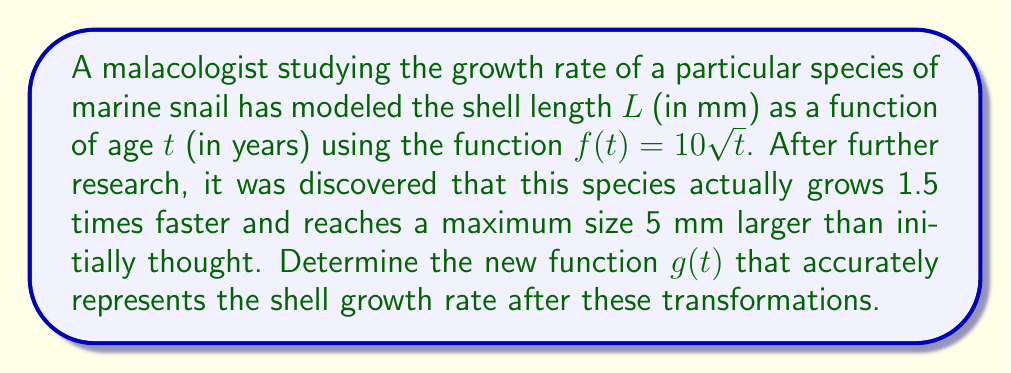Help me with this question. Let's approach this step-by-step:

1) The original function is $f(t) = 10\sqrt{t}$.

2) The species grows 1.5 times faster. This means we need to compress the function horizontally by a factor of 1.5. To do this, we replace $t$ with $\frac{t}{1.5}$:

   $f(\frac{t}{1.5}) = 10\sqrt{\frac{t}{1.5}}$

3) The species reaches a maximum size 5 mm larger. This means we need to shift the function vertically by 5 units:

   $f(\frac{t}{1.5}) + 5 = 10\sqrt{\frac{t}{1.5}} + 5$

4) Now, let's simplify the square root:

   $10\sqrt{\frac{t}{1.5}} + 5 = 10\sqrt{\frac{2t}{3}} + 5$

5) Therefore, the new function $g(t)$ that represents the adjusted growth rate is:

   $g(t) = 10\sqrt{\frac{2t}{3}} + 5$

This function represents a shell that grows 1.5 times faster (compressed horizontally) and reaches a maximum size 5 mm larger (shifted up vertically) compared to the original model.
Answer: $g(t) = 10\sqrt{\frac{2t}{3}} + 5$ 